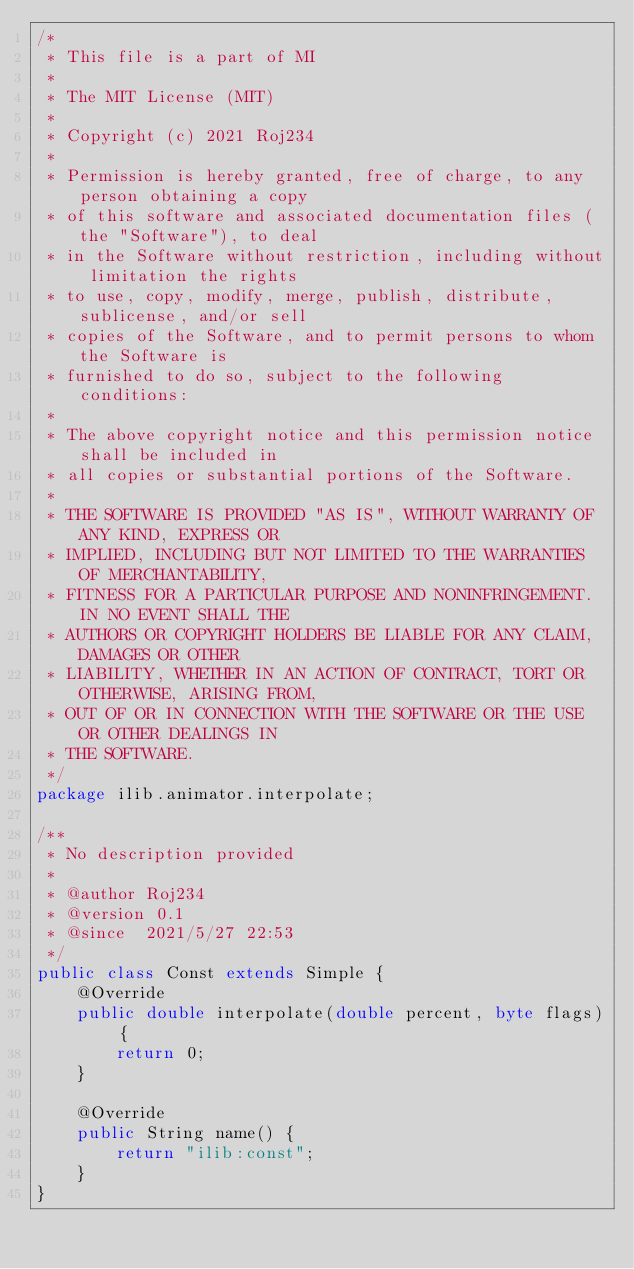<code> <loc_0><loc_0><loc_500><loc_500><_Java_>/*
 * This file is a part of MI
 *
 * The MIT License (MIT)
 *
 * Copyright (c) 2021 Roj234
 *
 * Permission is hereby granted, free of charge, to any person obtaining a copy
 * of this software and associated documentation files (the "Software"), to deal
 * in the Software without restriction, including without limitation the rights
 * to use, copy, modify, merge, publish, distribute, sublicense, and/or sell
 * copies of the Software, and to permit persons to whom the Software is
 * furnished to do so, subject to the following conditions:
 *
 * The above copyright notice and this permission notice shall be included in
 * all copies or substantial portions of the Software.
 *
 * THE SOFTWARE IS PROVIDED "AS IS", WITHOUT WARRANTY OF ANY KIND, EXPRESS OR
 * IMPLIED, INCLUDING BUT NOT LIMITED TO THE WARRANTIES OF MERCHANTABILITY,
 * FITNESS FOR A PARTICULAR PURPOSE AND NONINFRINGEMENT. IN NO EVENT SHALL THE
 * AUTHORS OR COPYRIGHT HOLDERS BE LIABLE FOR ANY CLAIM, DAMAGES OR OTHER
 * LIABILITY, WHETHER IN AN ACTION OF CONTRACT, TORT OR OTHERWISE, ARISING FROM,
 * OUT OF OR IN CONNECTION WITH THE SOFTWARE OR THE USE OR OTHER DEALINGS IN
 * THE SOFTWARE.
 */
package ilib.animator.interpolate;

/**
 * No description provided
 *
 * @author Roj234
 * @version 0.1
 * @since  2021/5/27 22:53
 */
public class Const extends Simple {
    @Override
    public double interpolate(double percent, byte flags) {
        return 0;
    }

    @Override
    public String name() {
        return "ilib:const";
    }
}
</code> 